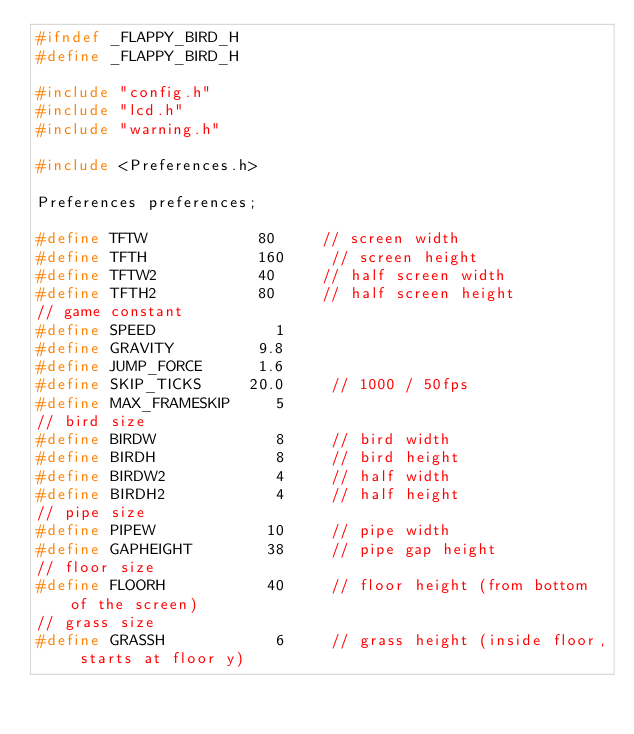Convert code to text. <code><loc_0><loc_0><loc_500><loc_500><_C_>#ifndef _FLAPPY_BIRD_H
#define _FLAPPY_BIRD_H

#include "config.h"
#include "lcd.h"
#include "warning.h"

#include <Preferences.h>

Preferences preferences;

#define TFTW            80     // screen width
#define TFTH            160     // screen height
#define TFTW2           40     // half screen width
#define TFTH2           80     // half screen height
// game constant
#define SPEED             1
#define GRAVITY         9.8
#define JUMP_FORCE      1.6
#define SKIP_TICKS     20.0     // 1000 / 50fps
#define MAX_FRAMESKIP     5
// bird size
#define BIRDW             8     // bird width
#define BIRDH             8     // bird height
#define BIRDW2            4     // half width
#define BIRDH2            4     // half height
// pipe size
#define PIPEW            10     // pipe width
#define GAPHEIGHT        38     // pipe gap height
// floor size
#define FLOORH           40     // floor height (from bottom of the screen)
// grass size
#define GRASSH            6     // grass height (inside floor, starts at floor y)
</code> 